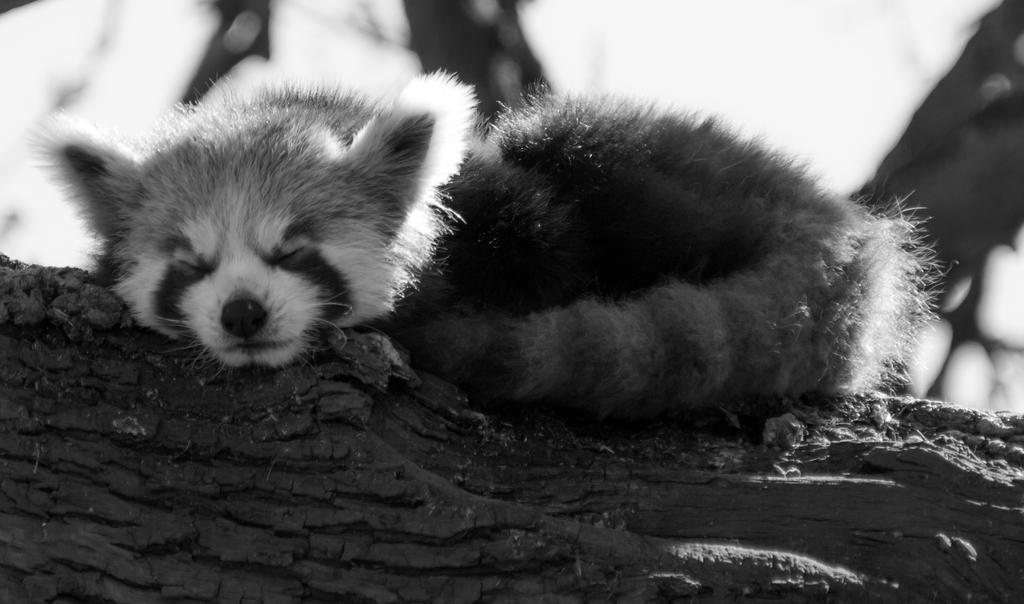What is the color scheme of the image? The image is in black and white. What type of subject can be seen in the image? There is an animal in the image. What is the animal doing in the image? The animal is lying on a wooden log. Where is the daughter sitting in the image? There is no daughter present in the image; it features an animal lying on a wooden log. What type of fish can be seen swimming in the image? There is no fish, goldfish or otherwise, present in the image. 